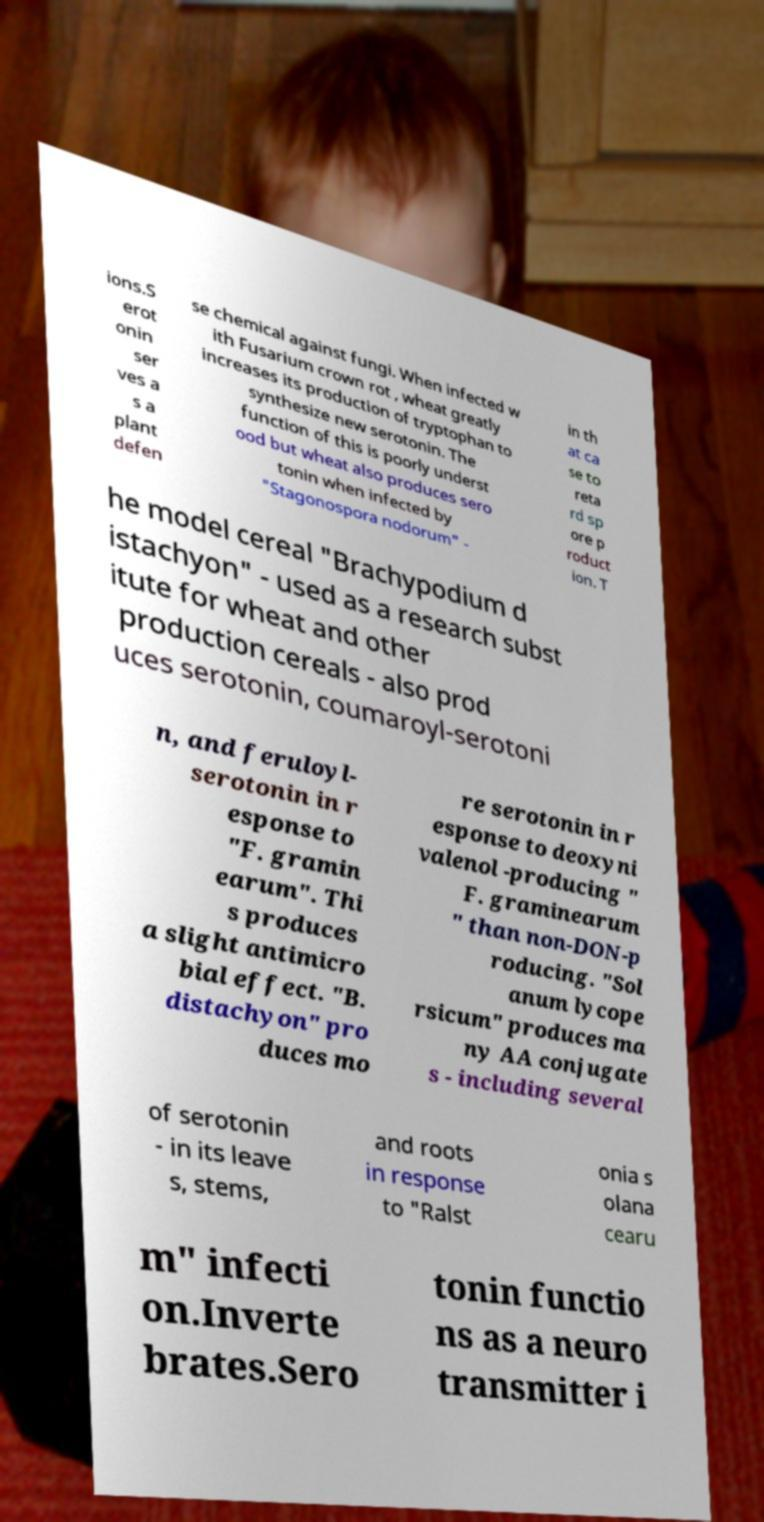What messages or text are displayed in this image? I need them in a readable, typed format. ions.S erot onin ser ves a s a plant defen se chemical against fungi. When infected w ith Fusarium crown rot , wheat greatly increases its production of tryptophan to synthesize new serotonin. The function of this is poorly underst ood but wheat also produces sero tonin when infected by "Stagonospora nodorum" - in th at ca se to reta rd sp ore p roduct ion. T he model cereal "Brachypodium d istachyon" - used as a research subst itute for wheat and other production cereals - also prod uces serotonin, coumaroyl-serotoni n, and feruloyl- serotonin in r esponse to "F. gramin earum". Thi s produces a slight antimicro bial effect. "B. distachyon" pro duces mo re serotonin in r esponse to deoxyni valenol -producing " F. graminearum " than non-DON-p roducing. "Sol anum lycope rsicum" produces ma ny AA conjugate s - including several of serotonin - in its leave s, stems, and roots in response to "Ralst onia s olana cearu m" infecti on.Inverte brates.Sero tonin functio ns as a neuro transmitter i 